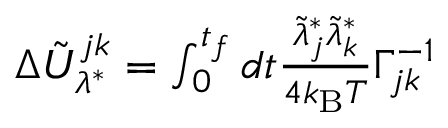Convert formula to latex. <formula><loc_0><loc_0><loc_500><loc_500>\begin{array} { r } { \Delta \tilde { U } _ { \lambda ^ { * } } ^ { j k } = \int _ { 0 } ^ { t _ { f } } d t \frac { \tilde { \lambda } _ { j } ^ { * } \tilde { \lambda } _ { k } ^ { * } } { 4 k _ { B } T } \Gamma _ { j k } ^ { - 1 } } \end{array}</formula> 